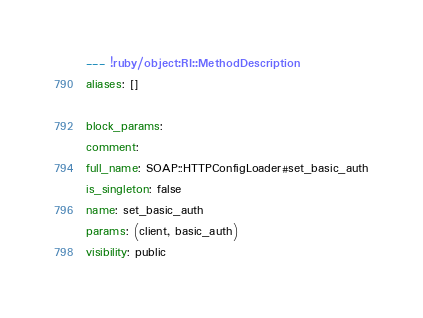Convert code to text. <code><loc_0><loc_0><loc_500><loc_500><_YAML_>--- !ruby/object:RI::MethodDescription 
aliases: []

block_params: 
comment: 
full_name: SOAP::HTTPConfigLoader#set_basic_auth
is_singleton: false
name: set_basic_auth
params: (client, basic_auth)
visibility: public
</code> 